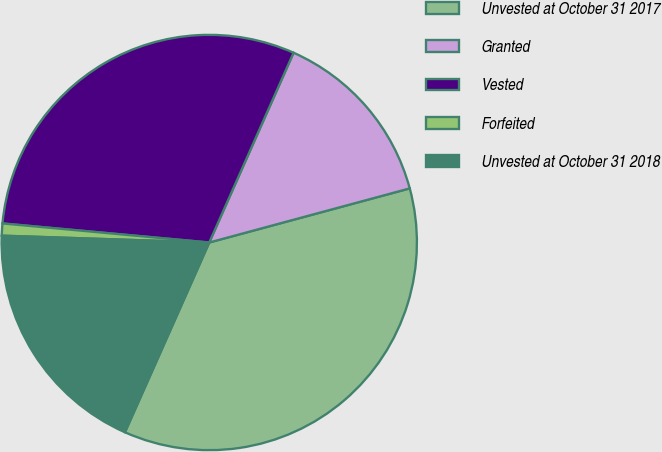Convert chart. <chart><loc_0><loc_0><loc_500><loc_500><pie_chart><fcel>Unvested at October 31 2017<fcel>Granted<fcel>Vested<fcel>Forfeited<fcel>Unvested at October 31 2018<nl><fcel>35.85%<fcel>14.15%<fcel>30.19%<fcel>0.94%<fcel>18.87%<nl></chart> 